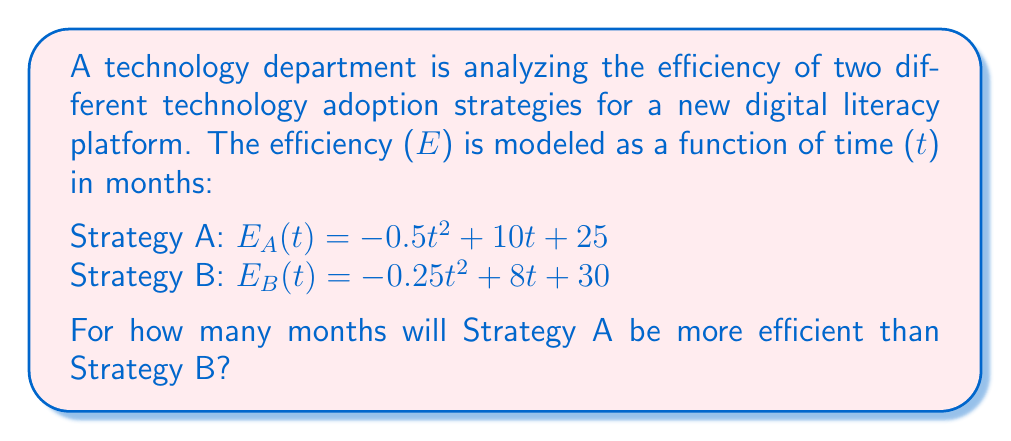What is the answer to this math problem? To solve this problem, we need to find the range of t where $E_A(t) > E_B(t)$.

Step 1: Set up the inequality
$E_A(t) > E_B(t)$
$-0.5t^2 + 10t + 25 > -0.25t^2 + 8t + 30$

Step 2: Rearrange the inequality
$-0.5t^2 + 10t + 25 - (-0.25t^2 + 8t + 30) > 0$
$-0.25t^2 + 2t - 5 > 0$

Step 3: Solve the quadratic inequality
Let $f(t) = -0.25t^2 + 2t - 5$

Find the roots of $f(t) = 0$:
$-0.25t^2 + 2t - 5 = 0$
$t = \frac{-2 \pm \sqrt{4 - 4(-0.25)(-5)}}{2(-0.25)}$
$t = \frac{-2 \pm \sqrt{4 - 5}}{-0.5}$
$t = \frac{-2 \pm \sqrt{-1}}{-0.5}$
$t = 4 \pm 2i$

Since the roots are complex, the parabola doesn't cross the x-axis. We need to determine if the parabola is above or below the x-axis.

Step 4: Check the y-intercept
$f(0) = -5 < 0$

The parabola is below the x-axis, so the inequality is never satisfied.

Step 5: Interpret the result
Since the inequality is never satisfied, Strategy A is never more efficient than Strategy B.
Answer: 0 months 